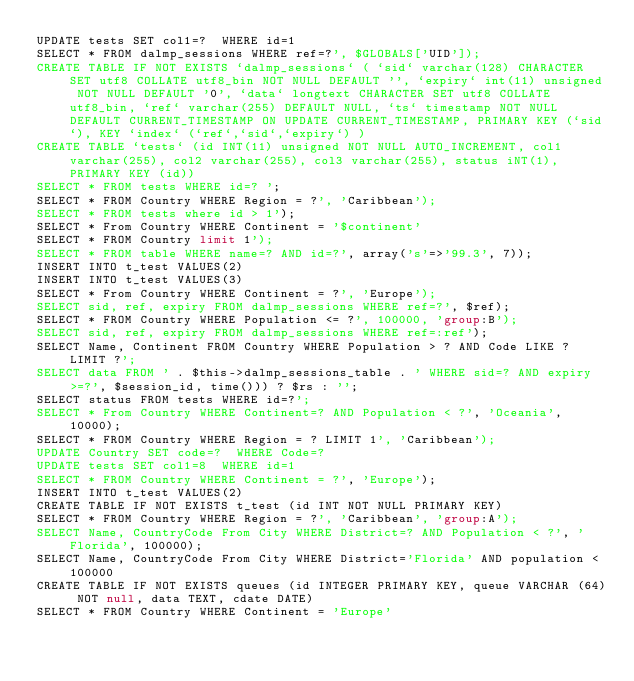<code> <loc_0><loc_0><loc_500><loc_500><_SQL_>UPDATE tests SET col1=?  WHERE id=1
SELECT * FROM dalmp_sessions WHERE ref=?', $GLOBALS['UID']);
CREATE TABLE IF NOT EXISTS `dalmp_sessions` ( `sid` varchar(128) CHARACTER SET utf8 COLLATE utf8_bin NOT NULL DEFAULT '', `expiry` int(11) unsigned NOT NULL DEFAULT '0', `data` longtext CHARACTER SET utf8 COLLATE utf8_bin, `ref` varchar(255) DEFAULT NULL, `ts` timestamp NOT NULL DEFAULT CURRENT_TIMESTAMP ON UPDATE CURRENT_TIMESTAMP, PRIMARY KEY (`sid`), KEY `index` (`ref`,`sid`,`expiry`) )
CREATE TABLE `tests` (id INT(11) unsigned NOT NULL AUTO_INCREMENT, col1 varchar(255), col2 varchar(255), col3 varchar(255), status iNT(1), PRIMARY KEY (id))
SELECT * FROM tests WHERE id=? ';
SELECT * FROM Country WHERE Region = ?', 'Caribbean');
SELECT * FROM tests where id > 1');
SELECT * From Country WHERE Continent = '$continent'
SELECT * FROM Country limit 1');
SELECT * FROM table WHERE name=? AND id=?', array('s'=>'99.3', 7));
INSERT INTO t_test VALUES(2)
INSERT INTO t_test VALUES(3)
SELECT * From Country WHERE Continent = ?', 'Europe');
SELECT sid, ref, expiry FROM dalmp_sessions WHERE ref=?', $ref);
SELECT * FROM Country WHERE Population <= ?', 100000, 'group:B');
SELECT sid, ref, expiry FROM dalmp_sessions WHERE ref=:ref');
SELECT Name, Continent FROM Country WHERE Population > ? AND Code LIKE ? LIMIT ?';
SELECT data FROM ' . $this->dalmp_sessions_table . ' WHERE sid=? AND expiry >=?', $session_id, time())) ? $rs : '';
SELECT status FROM tests WHERE id=?';
SELECT * From Country WHERE Continent=? AND Population < ?', 'Oceania', 10000);
SELECT * FROM Country WHERE Region = ? LIMIT 1', 'Caribbean');
UPDATE Country SET code=?  WHERE Code=?
UPDATE tests SET col1=8  WHERE id=1
SELECT * FROM Country WHERE Continent = ?', 'Europe');
INSERT INTO t_test VALUES(2)
CREATE TABLE IF NOT EXISTS t_test (id INT NOT NULL PRIMARY KEY)
SELECT * FROM Country WHERE Region = ?', 'Caribbean', 'group:A');
SELECT Name, CountryCode From City WHERE District=? AND Population < ?', 'Florida', 100000);
SELECT Name, CountryCode From City WHERE District='Florida' AND population < 100000
CREATE TABLE IF NOT EXISTS queues (id INTEGER PRIMARY KEY, queue VARCHAR (64) NOT null, data TEXT, cdate DATE)
SELECT * FROM Country WHERE Continent = 'Europe'</code> 